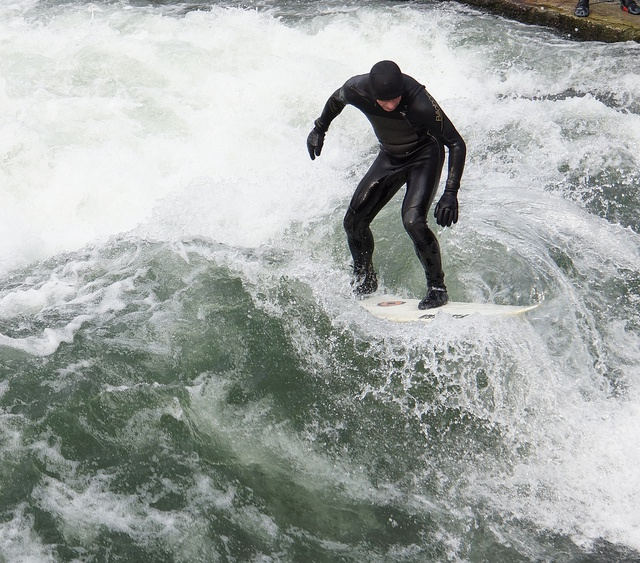Describe the objects in this image and their specific colors. I can see people in lightgray, black, gray, and darkgray tones, surfboard in lightgray, darkgray, and gray tones, and people in lightgray, black, gray, and darkblue tones in this image. 